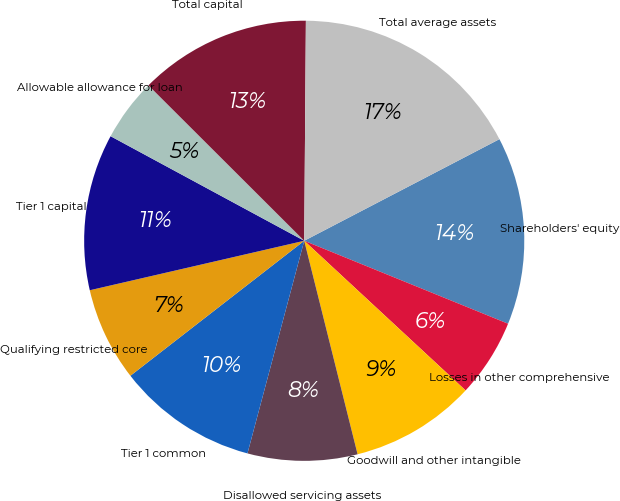Convert chart. <chart><loc_0><loc_0><loc_500><loc_500><pie_chart><fcel>Shareholders' equity<fcel>Losses in other comprehensive<fcel>Goodwill and other intangible<fcel>Disallowed servicing assets<fcel>Tier 1 common<fcel>Qualifying restricted core<fcel>Tier 1 capital<fcel>Allowable allowance for loan<fcel>Total capital<fcel>Total average assets<nl><fcel>13.79%<fcel>5.75%<fcel>9.2%<fcel>8.05%<fcel>10.34%<fcel>6.9%<fcel>11.49%<fcel>4.6%<fcel>12.64%<fcel>17.24%<nl></chart> 